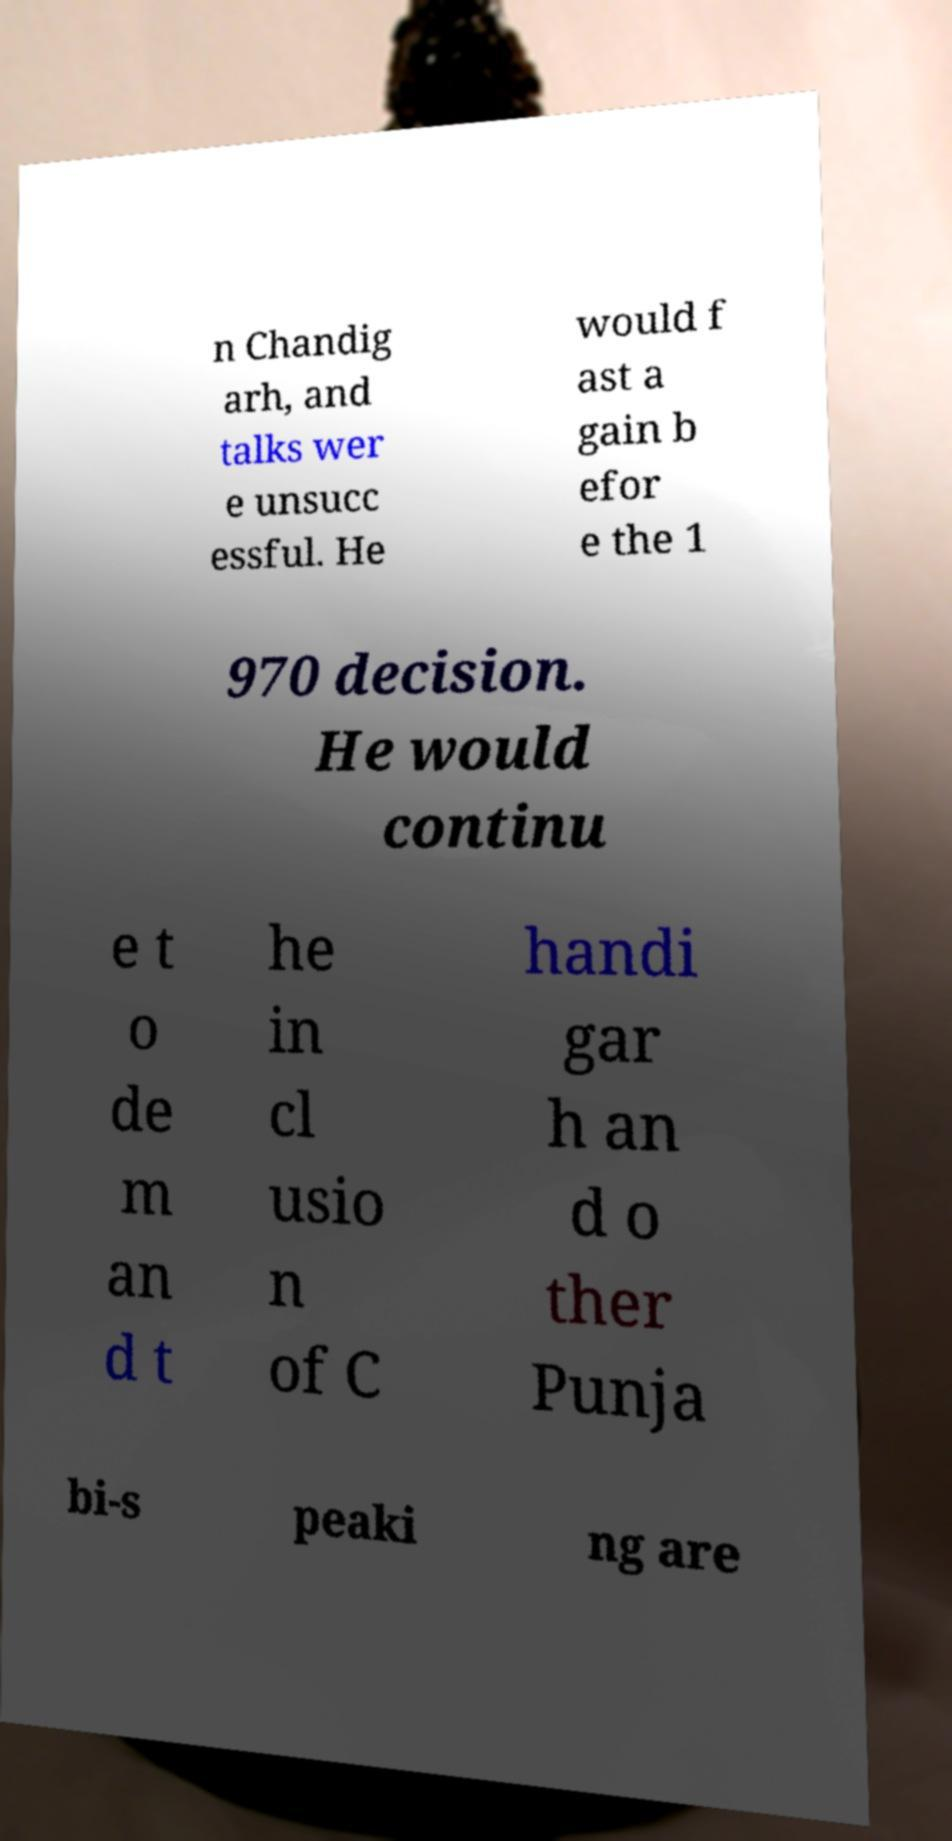Please read and relay the text visible in this image. What does it say? n Chandig arh, and talks wer e unsucc essful. He would f ast a gain b efor e the 1 970 decision. He would continu e t o de m an d t he in cl usio n of C handi gar h an d o ther Punja bi-s peaki ng are 